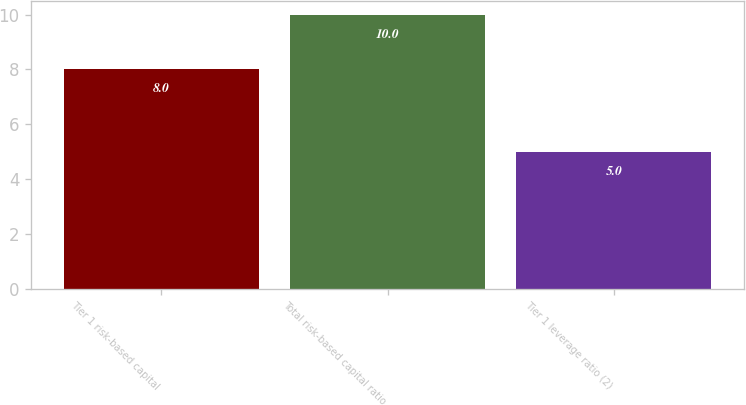Convert chart to OTSL. <chart><loc_0><loc_0><loc_500><loc_500><bar_chart><fcel>Tier 1 risk-based capital<fcel>Total risk-based capital ratio<fcel>Tier 1 leverage ratio (2)<nl><fcel>8<fcel>10<fcel>5<nl></chart> 